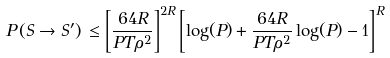<formula> <loc_0><loc_0><loc_500><loc_500>P \left ( S \rightarrow S ^ { \prime } \right ) \, \leq \left [ \frac { 6 4 R } { P T \rho ^ { 2 } } \right ] ^ { 2 R } \left [ \log ( P ) + \frac { 6 4 R } { P T \rho ^ { 2 } } \log ( P ) - 1 \right ] ^ { R }</formula> 